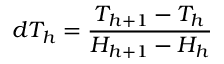Convert formula to latex. <formula><loc_0><loc_0><loc_500><loc_500>d T _ { h } = \frac { T _ { h + 1 } - T _ { h } } { H _ { h + 1 } - H _ { h } }</formula> 